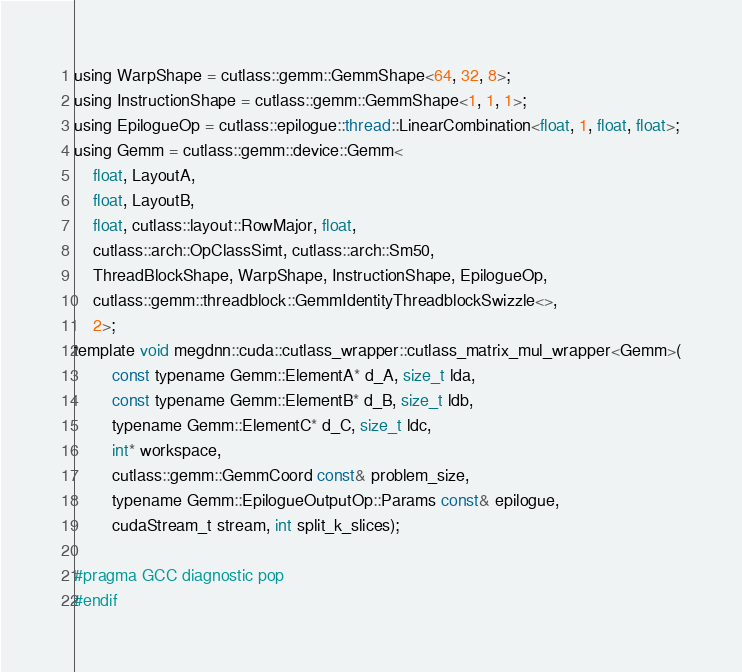Convert code to text. <code><loc_0><loc_0><loc_500><loc_500><_Cuda_>using WarpShape = cutlass::gemm::GemmShape<64, 32, 8>;
using InstructionShape = cutlass::gemm::GemmShape<1, 1, 1>;
using EpilogueOp = cutlass::epilogue::thread::LinearCombination<float, 1, float, float>;
using Gemm = cutlass::gemm::device::Gemm<
    float, LayoutA, 
    float, LayoutB, 
    float, cutlass::layout::RowMajor, float, 
    cutlass::arch::OpClassSimt, cutlass::arch::Sm50, 
    ThreadBlockShape, WarpShape, InstructionShape, EpilogueOp, 
    cutlass::gemm::threadblock::GemmIdentityThreadblockSwizzle<>, 
    2>;
template void megdnn::cuda::cutlass_wrapper::cutlass_matrix_mul_wrapper<Gemm>(
        const typename Gemm::ElementA* d_A, size_t lda, 
        const typename Gemm::ElementB* d_B, size_t ldb,  
        typename Gemm::ElementC* d_C, size_t ldc,  
        int* workspace, 
        cutlass::gemm::GemmCoord const& problem_size,   
        typename Gemm::EpilogueOutputOp::Params const& epilogue, 
        cudaStream_t stream, int split_k_slices);

#pragma GCC diagnostic pop
#endif
</code> 